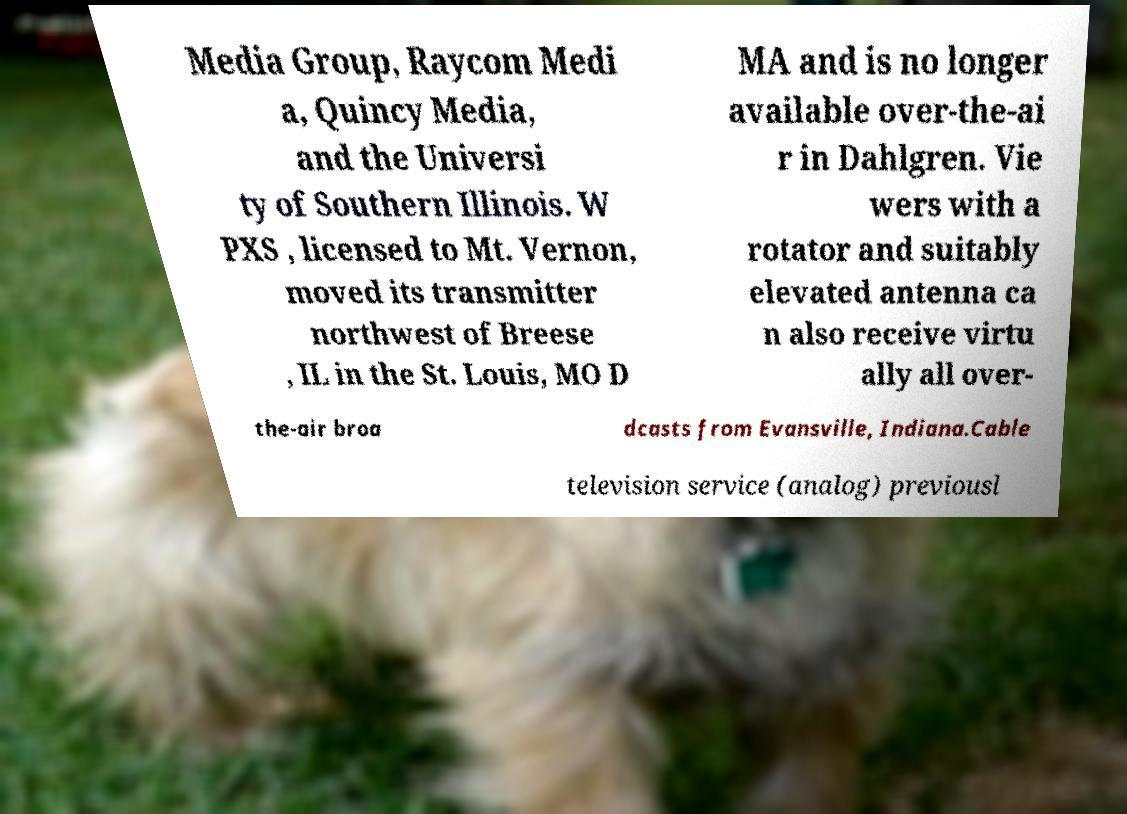Can you accurately transcribe the text from the provided image for me? Media Group, Raycom Medi a, Quincy Media, and the Universi ty of Southern Illinois. W PXS , licensed to Mt. Vernon, moved its transmitter northwest of Breese , IL in the St. Louis, MO D MA and is no longer available over-the-ai r in Dahlgren. Vie wers with a rotator and suitably elevated antenna ca n also receive virtu ally all over- the-air broa dcasts from Evansville, Indiana.Cable television service (analog) previousl 